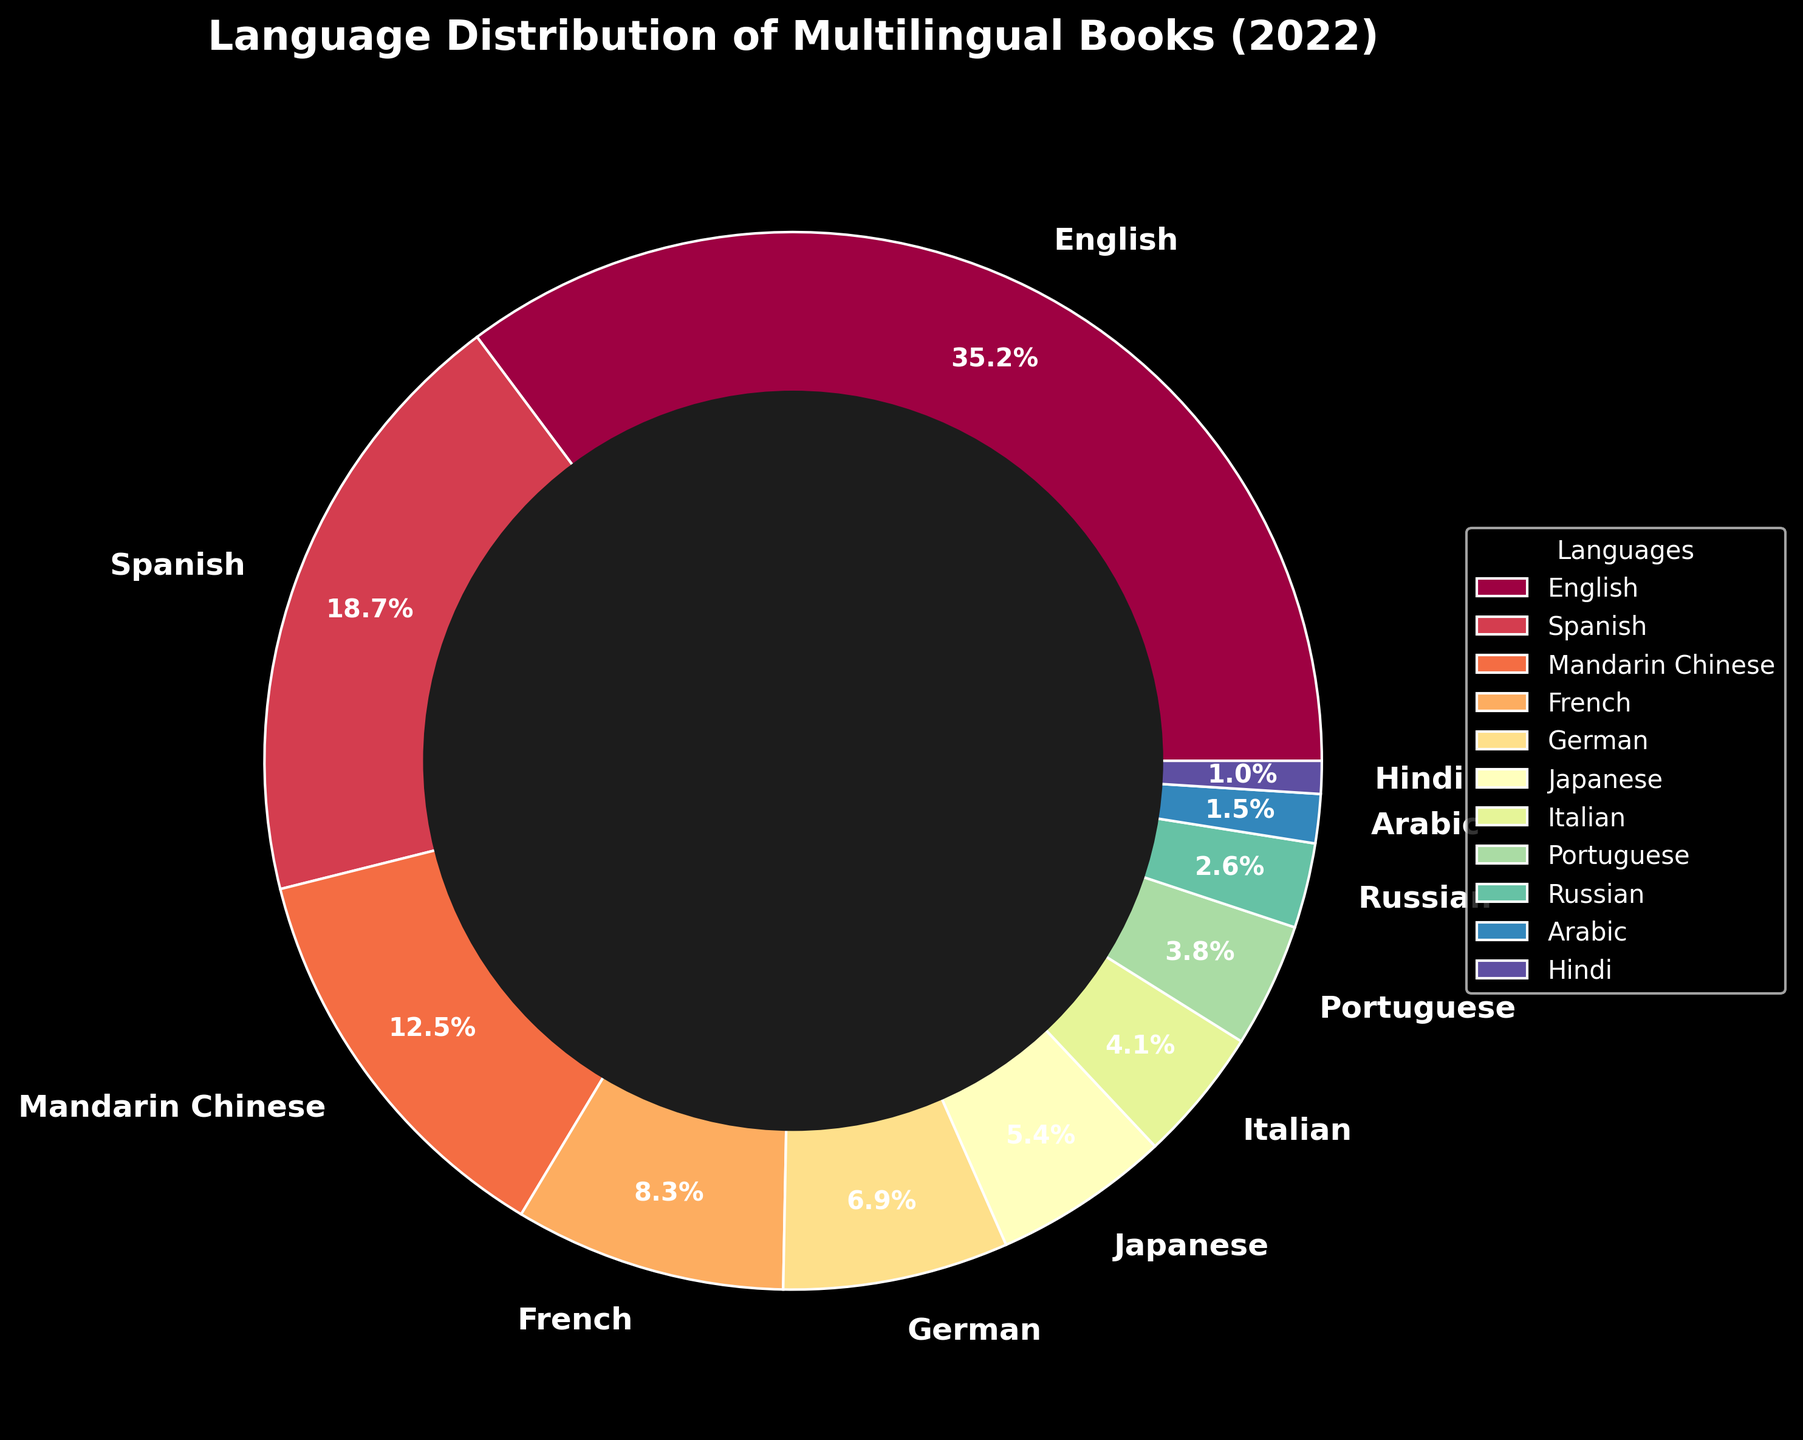Which language has the largest percentage of published multilingual books in 2022? By observing the size of the slices in the pie chart, we can see that the slice representing English is the largest, indicating it has the largest percentage.
Answer: English How many languages have a percentage higher than 10%? By looking at the pie chart, we can see that only three languages have slices larger than 10%: English, Spanish, and Mandarin Chinese.
Answer: 3 What is the combined percentage of books published in French and German? Summing the percentages of French (8.3%) and German (6.9%) gives 8.3 + 6.9 = 15.2%.
Answer: 15.2% Which language has a slightly higher percentage, Japanese or Italian? Comparing the two slices representing Japanese (5.4%) and Italian (4.1%), Japanese has a slightly higher percentage.
Answer: Japanese What is the difference in percentage between Spanish and Portuguese? The percentage for Spanish is 18.7% and for Portuguese is 3.8%. The difference is 18.7 - 3.8 = 14.9%.
Answer: 14.9% Order the languages by percentage from largest to smallest. By observing the sizes of the slices in descending order: English, Spanish, Mandarin Chinese, French, German, Japanese, Italian, Portuguese, Russian, Arabic, Hindi.
Answer: English, Spanish, Mandarin Chinese, French, German, Japanese, Italian, Portuguese, Russian, Arabic, Hindi What is the percentage of Arabic compared to the total percentage of German and Italian combined? Arabic has 1.5%, while German is 6.9% and Italian is 4.1%. The total for German and Italian combined is 6.9 + 4.1 = 11%. The percentage of Arabic compared to this is (1.5 / 11) * 100 = 13.64%.
Answer: 13.64% Are there more books published in Mandarin Chinese or in French and German combined? Mandarin Chinese has 12.5%. French and German combined have 8.3% + 6.9% = 15.2%. Since 15.2 > 12.5, more books were published in French and German combined.
Answer: French and German combined 